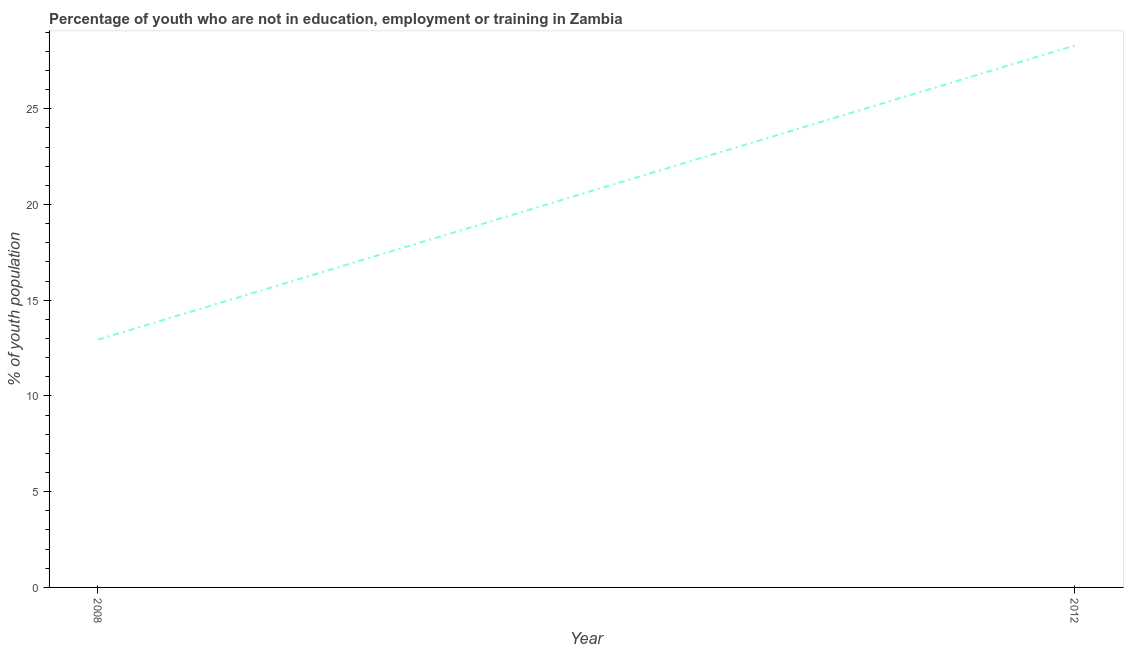What is the unemployed youth population in 2008?
Provide a short and direct response. 12.94. Across all years, what is the maximum unemployed youth population?
Offer a very short reply. 28.3. Across all years, what is the minimum unemployed youth population?
Your response must be concise. 12.94. In which year was the unemployed youth population maximum?
Give a very brief answer. 2012. In which year was the unemployed youth population minimum?
Provide a short and direct response. 2008. What is the sum of the unemployed youth population?
Provide a succinct answer. 41.24. What is the difference between the unemployed youth population in 2008 and 2012?
Offer a very short reply. -15.36. What is the average unemployed youth population per year?
Keep it short and to the point. 20.62. What is the median unemployed youth population?
Your answer should be very brief. 20.62. Do a majority of the years between 2012 and 2008 (inclusive) have unemployed youth population greater than 21 %?
Your answer should be very brief. No. What is the ratio of the unemployed youth population in 2008 to that in 2012?
Give a very brief answer. 0.46. Does the unemployed youth population monotonically increase over the years?
Keep it short and to the point. Yes. How many lines are there?
Give a very brief answer. 1. What is the difference between two consecutive major ticks on the Y-axis?
Offer a terse response. 5. Does the graph contain grids?
Provide a short and direct response. No. What is the title of the graph?
Provide a short and direct response. Percentage of youth who are not in education, employment or training in Zambia. What is the label or title of the X-axis?
Provide a short and direct response. Year. What is the label or title of the Y-axis?
Offer a terse response. % of youth population. What is the % of youth population of 2008?
Offer a terse response. 12.94. What is the % of youth population in 2012?
Provide a short and direct response. 28.3. What is the difference between the % of youth population in 2008 and 2012?
Ensure brevity in your answer.  -15.36. What is the ratio of the % of youth population in 2008 to that in 2012?
Provide a succinct answer. 0.46. 